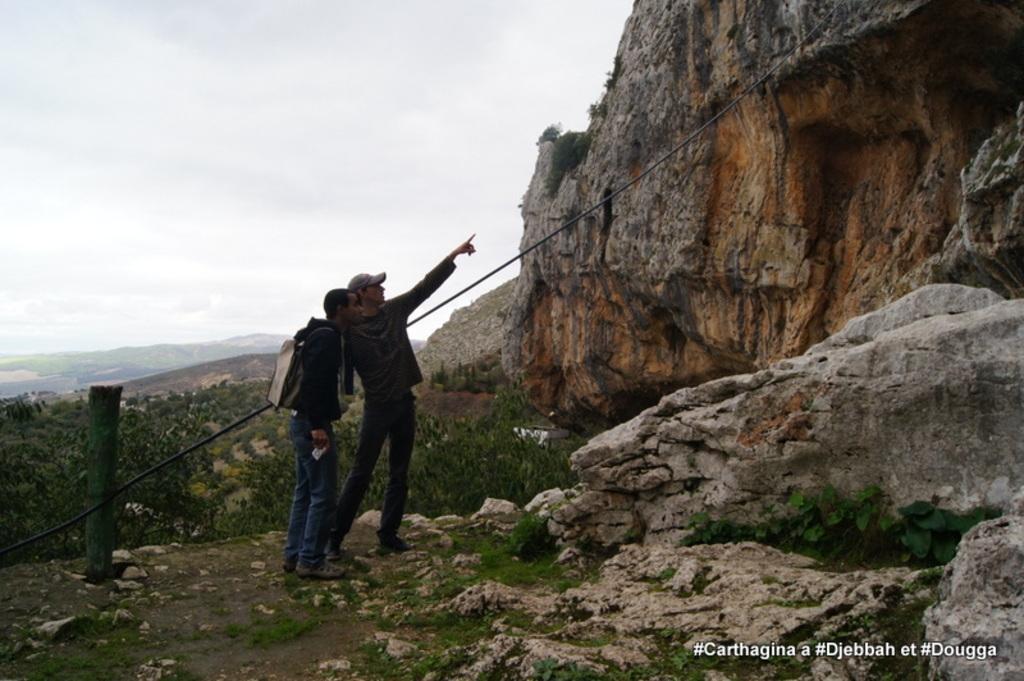Please provide a concise description of this image. This image consists of two persons in the middle. They are wearing black dress. There is something like mountain on the right side. There is sky at the top. 